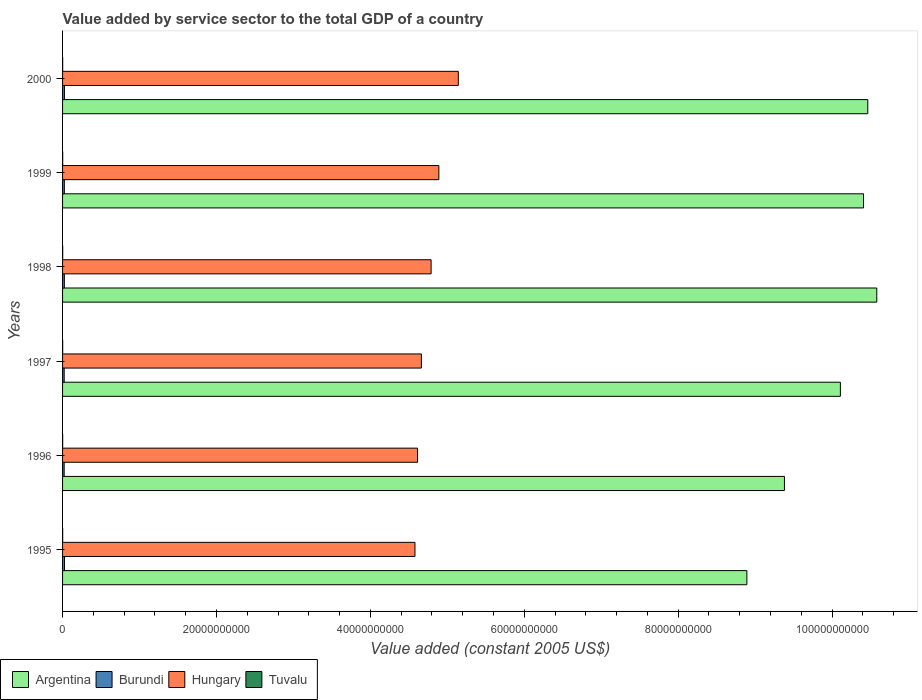Are the number of bars per tick equal to the number of legend labels?
Ensure brevity in your answer.  Yes. How many bars are there on the 1st tick from the bottom?
Make the answer very short. 4. What is the label of the 3rd group of bars from the top?
Make the answer very short. 1998. In how many cases, is the number of bars for a given year not equal to the number of legend labels?
Ensure brevity in your answer.  0. What is the value added by service sector in Burundi in 1998?
Ensure brevity in your answer.  2.31e+08. Across all years, what is the maximum value added by service sector in Argentina?
Your answer should be compact. 1.06e+11. Across all years, what is the minimum value added by service sector in Tuvalu?
Offer a very short reply. 1.20e+07. In which year was the value added by service sector in Hungary minimum?
Keep it short and to the point. 1995. What is the total value added by service sector in Hungary in the graph?
Ensure brevity in your answer.  2.87e+11. What is the difference between the value added by service sector in Burundi in 1996 and that in 1997?
Offer a terse response. -3.13e+06. What is the difference between the value added by service sector in Argentina in 1996 and the value added by service sector in Hungary in 1999?
Your answer should be very brief. 4.49e+1. What is the average value added by service sector in Hungary per year?
Ensure brevity in your answer.  4.78e+1. In the year 1999, what is the difference between the value added by service sector in Tuvalu and value added by service sector in Burundi?
Provide a short and direct response. -2.15e+08. What is the ratio of the value added by service sector in Hungary in 1995 to that in 1999?
Offer a terse response. 0.94. What is the difference between the highest and the second highest value added by service sector in Tuvalu?
Provide a short and direct response. 3.08e+05. What is the difference between the highest and the lowest value added by service sector in Tuvalu?
Your response must be concise. 4.40e+06. In how many years, is the value added by service sector in Hungary greater than the average value added by service sector in Hungary taken over all years?
Offer a very short reply. 3. Is the sum of the value added by service sector in Hungary in 1995 and 2000 greater than the maximum value added by service sector in Argentina across all years?
Make the answer very short. No. Is it the case that in every year, the sum of the value added by service sector in Hungary and value added by service sector in Burundi is greater than the sum of value added by service sector in Argentina and value added by service sector in Tuvalu?
Ensure brevity in your answer.  Yes. What does the 1st bar from the top in 1995 represents?
Ensure brevity in your answer.  Tuvalu. What does the 3rd bar from the bottom in 1995 represents?
Make the answer very short. Hungary. How many bars are there?
Provide a succinct answer. 24. Are all the bars in the graph horizontal?
Your answer should be very brief. Yes. How many years are there in the graph?
Provide a succinct answer. 6. How many legend labels are there?
Ensure brevity in your answer.  4. What is the title of the graph?
Give a very brief answer. Value added by service sector to the total GDP of a country. What is the label or title of the X-axis?
Your answer should be very brief. Value added (constant 2005 US$). What is the Value added (constant 2005 US$) in Argentina in 1995?
Keep it short and to the point. 8.89e+1. What is the Value added (constant 2005 US$) in Burundi in 1995?
Make the answer very short. 2.49e+08. What is the Value added (constant 2005 US$) in Hungary in 1995?
Make the answer very short. 4.58e+1. What is the Value added (constant 2005 US$) in Tuvalu in 1995?
Make the answer very short. 1.32e+07. What is the Value added (constant 2005 US$) in Argentina in 1996?
Keep it short and to the point. 9.38e+1. What is the Value added (constant 2005 US$) in Burundi in 1996?
Your response must be concise. 2.07e+08. What is the Value added (constant 2005 US$) of Hungary in 1996?
Make the answer very short. 4.61e+1. What is the Value added (constant 2005 US$) in Tuvalu in 1996?
Your response must be concise. 1.20e+07. What is the Value added (constant 2005 US$) in Argentina in 1997?
Your response must be concise. 1.01e+11. What is the Value added (constant 2005 US$) of Burundi in 1997?
Keep it short and to the point. 2.10e+08. What is the Value added (constant 2005 US$) of Hungary in 1997?
Offer a terse response. 4.66e+1. What is the Value added (constant 2005 US$) in Tuvalu in 1997?
Ensure brevity in your answer.  1.35e+07. What is the Value added (constant 2005 US$) in Argentina in 1998?
Provide a succinct answer. 1.06e+11. What is the Value added (constant 2005 US$) of Burundi in 1998?
Keep it short and to the point. 2.31e+08. What is the Value added (constant 2005 US$) of Hungary in 1998?
Your answer should be very brief. 4.79e+1. What is the Value added (constant 2005 US$) of Tuvalu in 1998?
Offer a very short reply. 1.64e+07. What is the Value added (constant 2005 US$) of Argentina in 1999?
Your answer should be compact. 1.04e+11. What is the Value added (constant 2005 US$) of Burundi in 1999?
Keep it short and to the point. 2.31e+08. What is the Value added (constant 2005 US$) of Hungary in 1999?
Your answer should be very brief. 4.89e+1. What is the Value added (constant 2005 US$) of Tuvalu in 1999?
Offer a very short reply. 1.61e+07. What is the Value added (constant 2005 US$) in Argentina in 2000?
Give a very brief answer. 1.05e+11. What is the Value added (constant 2005 US$) of Burundi in 2000?
Give a very brief answer. 2.44e+08. What is the Value added (constant 2005 US$) in Hungary in 2000?
Provide a short and direct response. 5.14e+1. What is the Value added (constant 2005 US$) of Tuvalu in 2000?
Give a very brief answer. 1.32e+07. Across all years, what is the maximum Value added (constant 2005 US$) of Argentina?
Your response must be concise. 1.06e+11. Across all years, what is the maximum Value added (constant 2005 US$) in Burundi?
Ensure brevity in your answer.  2.49e+08. Across all years, what is the maximum Value added (constant 2005 US$) of Hungary?
Offer a very short reply. 5.14e+1. Across all years, what is the maximum Value added (constant 2005 US$) in Tuvalu?
Ensure brevity in your answer.  1.64e+07. Across all years, what is the minimum Value added (constant 2005 US$) in Argentina?
Your response must be concise. 8.89e+1. Across all years, what is the minimum Value added (constant 2005 US$) of Burundi?
Provide a succinct answer. 2.07e+08. Across all years, what is the minimum Value added (constant 2005 US$) in Hungary?
Provide a succinct answer. 4.58e+1. Across all years, what is the minimum Value added (constant 2005 US$) in Tuvalu?
Keep it short and to the point. 1.20e+07. What is the total Value added (constant 2005 US$) of Argentina in the graph?
Your response must be concise. 5.98e+11. What is the total Value added (constant 2005 US$) in Burundi in the graph?
Your answer should be compact. 1.37e+09. What is the total Value added (constant 2005 US$) in Hungary in the graph?
Keep it short and to the point. 2.87e+11. What is the total Value added (constant 2005 US$) in Tuvalu in the graph?
Give a very brief answer. 8.42e+07. What is the difference between the Value added (constant 2005 US$) in Argentina in 1995 and that in 1996?
Offer a very short reply. -4.88e+09. What is the difference between the Value added (constant 2005 US$) of Burundi in 1995 and that in 1996?
Your response must be concise. 4.22e+07. What is the difference between the Value added (constant 2005 US$) of Hungary in 1995 and that in 1996?
Offer a very short reply. -3.36e+08. What is the difference between the Value added (constant 2005 US$) of Tuvalu in 1995 and that in 1996?
Your answer should be very brief. 1.20e+06. What is the difference between the Value added (constant 2005 US$) of Argentina in 1995 and that in 1997?
Your response must be concise. -1.21e+1. What is the difference between the Value added (constant 2005 US$) in Burundi in 1995 and that in 1997?
Offer a terse response. 3.91e+07. What is the difference between the Value added (constant 2005 US$) of Hungary in 1995 and that in 1997?
Ensure brevity in your answer.  -8.33e+08. What is the difference between the Value added (constant 2005 US$) of Tuvalu in 1995 and that in 1997?
Provide a succinct answer. -3.17e+05. What is the difference between the Value added (constant 2005 US$) of Argentina in 1995 and that in 1998?
Offer a terse response. -1.69e+1. What is the difference between the Value added (constant 2005 US$) of Burundi in 1995 and that in 1998?
Ensure brevity in your answer.  1.79e+07. What is the difference between the Value added (constant 2005 US$) of Hungary in 1995 and that in 1998?
Provide a short and direct response. -2.10e+09. What is the difference between the Value added (constant 2005 US$) in Tuvalu in 1995 and that in 1998?
Make the answer very short. -3.20e+06. What is the difference between the Value added (constant 2005 US$) in Argentina in 1995 and that in 1999?
Your response must be concise. -1.52e+1. What is the difference between the Value added (constant 2005 US$) in Burundi in 1995 and that in 1999?
Keep it short and to the point. 1.80e+07. What is the difference between the Value added (constant 2005 US$) in Hungary in 1995 and that in 1999?
Your answer should be very brief. -3.10e+09. What is the difference between the Value added (constant 2005 US$) in Tuvalu in 1995 and that in 1999?
Keep it short and to the point. -2.89e+06. What is the difference between the Value added (constant 2005 US$) of Argentina in 1995 and that in 2000?
Provide a succinct answer. -1.57e+1. What is the difference between the Value added (constant 2005 US$) in Burundi in 1995 and that in 2000?
Provide a short and direct response. 5.33e+06. What is the difference between the Value added (constant 2005 US$) of Hungary in 1995 and that in 2000?
Provide a short and direct response. -5.63e+09. What is the difference between the Value added (constant 2005 US$) in Tuvalu in 1995 and that in 2000?
Give a very brief answer. 6949.36. What is the difference between the Value added (constant 2005 US$) in Argentina in 1996 and that in 1997?
Keep it short and to the point. -7.27e+09. What is the difference between the Value added (constant 2005 US$) of Burundi in 1996 and that in 1997?
Provide a succinct answer. -3.13e+06. What is the difference between the Value added (constant 2005 US$) in Hungary in 1996 and that in 1997?
Provide a short and direct response. -4.97e+08. What is the difference between the Value added (constant 2005 US$) in Tuvalu in 1996 and that in 1997?
Provide a short and direct response. -1.52e+06. What is the difference between the Value added (constant 2005 US$) of Argentina in 1996 and that in 1998?
Keep it short and to the point. -1.20e+1. What is the difference between the Value added (constant 2005 US$) in Burundi in 1996 and that in 1998?
Ensure brevity in your answer.  -2.43e+07. What is the difference between the Value added (constant 2005 US$) of Hungary in 1996 and that in 1998?
Make the answer very short. -1.76e+09. What is the difference between the Value added (constant 2005 US$) of Tuvalu in 1996 and that in 1998?
Your response must be concise. -4.40e+06. What is the difference between the Value added (constant 2005 US$) of Argentina in 1996 and that in 1999?
Provide a short and direct response. -1.03e+1. What is the difference between the Value added (constant 2005 US$) in Burundi in 1996 and that in 1999?
Keep it short and to the point. -2.42e+07. What is the difference between the Value added (constant 2005 US$) of Hungary in 1996 and that in 1999?
Offer a very short reply. -2.77e+09. What is the difference between the Value added (constant 2005 US$) of Tuvalu in 1996 and that in 1999?
Make the answer very short. -4.09e+06. What is the difference between the Value added (constant 2005 US$) of Argentina in 1996 and that in 2000?
Offer a terse response. -1.08e+1. What is the difference between the Value added (constant 2005 US$) of Burundi in 1996 and that in 2000?
Your answer should be compact. -3.69e+07. What is the difference between the Value added (constant 2005 US$) of Hungary in 1996 and that in 2000?
Provide a succinct answer. -5.30e+09. What is the difference between the Value added (constant 2005 US$) of Tuvalu in 1996 and that in 2000?
Your answer should be compact. -1.19e+06. What is the difference between the Value added (constant 2005 US$) of Argentina in 1997 and that in 1998?
Offer a very short reply. -4.73e+09. What is the difference between the Value added (constant 2005 US$) in Burundi in 1997 and that in 1998?
Offer a terse response. -2.12e+07. What is the difference between the Value added (constant 2005 US$) of Hungary in 1997 and that in 1998?
Offer a terse response. -1.26e+09. What is the difference between the Value added (constant 2005 US$) in Tuvalu in 1997 and that in 1998?
Provide a succinct answer. -2.88e+06. What is the difference between the Value added (constant 2005 US$) in Argentina in 1997 and that in 1999?
Your response must be concise. -3.01e+09. What is the difference between the Value added (constant 2005 US$) of Burundi in 1997 and that in 1999?
Provide a succinct answer. -2.11e+07. What is the difference between the Value added (constant 2005 US$) of Hungary in 1997 and that in 1999?
Make the answer very short. -2.27e+09. What is the difference between the Value added (constant 2005 US$) in Tuvalu in 1997 and that in 1999?
Ensure brevity in your answer.  -2.58e+06. What is the difference between the Value added (constant 2005 US$) in Argentina in 1997 and that in 2000?
Your answer should be very brief. -3.56e+09. What is the difference between the Value added (constant 2005 US$) of Burundi in 1997 and that in 2000?
Offer a terse response. -3.38e+07. What is the difference between the Value added (constant 2005 US$) of Hungary in 1997 and that in 2000?
Ensure brevity in your answer.  -4.80e+09. What is the difference between the Value added (constant 2005 US$) of Tuvalu in 1997 and that in 2000?
Provide a succinct answer. 3.24e+05. What is the difference between the Value added (constant 2005 US$) in Argentina in 1998 and that in 1999?
Keep it short and to the point. 1.72e+09. What is the difference between the Value added (constant 2005 US$) of Burundi in 1998 and that in 1999?
Provide a succinct answer. 7.54e+04. What is the difference between the Value added (constant 2005 US$) of Hungary in 1998 and that in 1999?
Ensure brevity in your answer.  -1.01e+09. What is the difference between the Value added (constant 2005 US$) in Tuvalu in 1998 and that in 1999?
Your answer should be compact. 3.08e+05. What is the difference between the Value added (constant 2005 US$) in Argentina in 1998 and that in 2000?
Keep it short and to the point. 1.17e+09. What is the difference between the Value added (constant 2005 US$) of Burundi in 1998 and that in 2000?
Make the answer very short. -1.26e+07. What is the difference between the Value added (constant 2005 US$) of Hungary in 1998 and that in 2000?
Offer a terse response. -3.54e+09. What is the difference between the Value added (constant 2005 US$) of Tuvalu in 1998 and that in 2000?
Provide a succinct answer. 3.21e+06. What is the difference between the Value added (constant 2005 US$) of Argentina in 1999 and that in 2000?
Offer a very short reply. -5.52e+08. What is the difference between the Value added (constant 2005 US$) of Burundi in 1999 and that in 2000?
Your response must be concise. -1.27e+07. What is the difference between the Value added (constant 2005 US$) in Hungary in 1999 and that in 2000?
Offer a very short reply. -2.53e+09. What is the difference between the Value added (constant 2005 US$) in Tuvalu in 1999 and that in 2000?
Your answer should be very brief. 2.90e+06. What is the difference between the Value added (constant 2005 US$) in Argentina in 1995 and the Value added (constant 2005 US$) in Burundi in 1996?
Offer a terse response. 8.87e+1. What is the difference between the Value added (constant 2005 US$) of Argentina in 1995 and the Value added (constant 2005 US$) of Hungary in 1996?
Your response must be concise. 4.28e+1. What is the difference between the Value added (constant 2005 US$) of Argentina in 1995 and the Value added (constant 2005 US$) of Tuvalu in 1996?
Keep it short and to the point. 8.89e+1. What is the difference between the Value added (constant 2005 US$) in Burundi in 1995 and the Value added (constant 2005 US$) in Hungary in 1996?
Your answer should be very brief. -4.59e+1. What is the difference between the Value added (constant 2005 US$) in Burundi in 1995 and the Value added (constant 2005 US$) in Tuvalu in 1996?
Give a very brief answer. 2.37e+08. What is the difference between the Value added (constant 2005 US$) of Hungary in 1995 and the Value added (constant 2005 US$) of Tuvalu in 1996?
Offer a very short reply. 4.58e+1. What is the difference between the Value added (constant 2005 US$) in Argentina in 1995 and the Value added (constant 2005 US$) in Burundi in 1997?
Your answer should be compact. 8.87e+1. What is the difference between the Value added (constant 2005 US$) of Argentina in 1995 and the Value added (constant 2005 US$) of Hungary in 1997?
Offer a very short reply. 4.23e+1. What is the difference between the Value added (constant 2005 US$) in Argentina in 1995 and the Value added (constant 2005 US$) in Tuvalu in 1997?
Keep it short and to the point. 8.89e+1. What is the difference between the Value added (constant 2005 US$) in Burundi in 1995 and the Value added (constant 2005 US$) in Hungary in 1997?
Your answer should be compact. -4.64e+1. What is the difference between the Value added (constant 2005 US$) in Burundi in 1995 and the Value added (constant 2005 US$) in Tuvalu in 1997?
Keep it short and to the point. 2.36e+08. What is the difference between the Value added (constant 2005 US$) of Hungary in 1995 and the Value added (constant 2005 US$) of Tuvalu in 1997?
Provide a succinct answer. 4.58e+1. What is the difference between the Value added (constant 2005 US$) of Argentina in 1995 and the Value added (constant 2005 US$) of Burundi in 1998?
Offer a terse response. 8.87e+1. What is the difference between the Value added (constant 2005 US$) in Argentina in 1995 and the Value added (constant 2005 US$) in Hungary in 1998?
Your response must be concise. 4.10e+1. What is the difference between the Value added (constant 2005 US$) in Argentina in 1995 and the Value added (constant 2005 US$) in Tuvalu in 1998?
Your answer should be very brief. 8.89e+1. What is the difference between the Value added (constant 2005 US$) in Burundi in 1995 and the Value added (constant 2005 US$) in Hungary in 1998?
Provide a succinct answer. -4.76e+1. What is the difference between the Value added (constant 2005 US$) in Burundi in 1995 and the Value added (constant 2005 US$) in Tuvalu in 1998?
Ensure brevity in your answer.  2.33e+08. What is the difference between the Value added (constant 2005 US$) in Hungary in 1995 and the Value added (constant 2005 US$) in Tuvalu in 1998?
Your response must be concise. 4.58e+1. What is the difference between the Value added (constant 2005 US$) of Argentina in 1995 and the Value added (constant 2005 US$) of Burundi in 1999?
Ensure brevity in your answer.  8.87e+1. What is the difference between the Value added (constant 2005 US$) in Argentina in 1995 and the Value added (constant 2005 US$) in Hungary in 1999?
Your answer should be compact. 4.00e+1. What is the difference between the Value added (constant 2005 US$) of Argentina in 1995 and the Value added (constant 2005 US$) of Tuvalu in 1999?
Keep it short and to the point. 8.89e+1. What is the difference between the Value added (constant 2005 US$) of Burundi in 1995 and the Value added (constant 2005 US$) of Hungary in 1999?
Offer a very short reply. -4.86e+1. What is the difference between the Value added (constant 2005 US$) in Burundi in 1995 and the Value added (constant 2005 US$) in Tuvalu in 1999?
Your response must be concise. 2.33e+08. What is the difference between the Value added (constant 2005 US$) in Hungary in 1995 and the Value added (constant 2005 US$) in Tuvalu in 1999?
Offer a terse response. 4.58e+1. What is the difference between the Value added (constant 2005 US$) in Argentina in 1995 and the Value added (constant 2005 US$) in Burundi in 2000?
Make the answer very short. 8.87e+1. What is the difference between the Value added (constant 2005 US$) of Argentina in 1995 and the Value added (constant 2005 US$) of Hungary in 2000?
Your answer should be compact. 3.75e+1. What is the difference between the Value added (constant 2005 US$) of Argentina in 1995 and the Value added (constant 2005 US$) of Tuvalu in 2000?
Give a very brief answer. 8.89e+1. What is the difference between the Value added (constant 2005 US$) of Burundi in 1995 and the Value added (constant 2005 US$) of Hungary in 2000?
Ensure brevity in your answer.  -5.12e+1. What is the difference between the Value added (constant 2005 US$) of Burundi in 1995 and the Value added (constant 2005 US$) of Tuvalu in 2000?
Provide a succinct answer. 2.36e+08. What is the difference between the Value added (constant 2005 US$) in Hungary in 1995 and the Value added (constant 2005 US$) in Tuvalu in 2000?
Offer a terse response. 4.58e+1. What is the difference between the Value added (constant 2005 US$) of Argentina in 1996 and the Value added (constant 2005 US$) of Burundi in 1997?
Offer a terse response. 9.36e+1. What is the difference between the Value added (constant 2005 US$) of Argentina in 1996 and the Value added (constant 2005 US$) of Hungary in 1997?
Ensure brevity in your answer.  4.72e+1. What is the difference between the Value added (constant 2005 US$) of Argentina in 1996 and the Value added (constant 2005 US$) of Tuvalu in 1997?
Ensure brevity in your answer.  9.38e+1. What is the difference between the Value added (constant 2005 US$) in Burundi in 1996 and the Value added (constant 2005 US$) in Hungary in 1997?
Provide a succinct answer. -4.64e+1. What is the difference between the Value added (constant 2005 US$) in Burundi in 1996 and the Value added (constant 2005 US$) in Tuvalu in 1997?
Keep it short and to the point. 1.94e+08. What is the difference between the Value added (constant 2005 US$) of Hungary in 1996 and the Value added (constant 2005 US$) of Tuvalu in 1997?
Provide a succinct answer. 4.61e+1. What is the difference between the Value added (constant 2005 US$) of Argentina in 1996 and the Value added (constant 2005 US$) of Burundi in 1998?
Provide a short and direct response. 9.36e+1. What is the difference between the Value added (constant 2005 US$) of Argentina in 1996 and the Value added (constant 2005 US$) of Hungary in 1998?
Ensure brevity in your answer.  4.59e+1. What is the difference between the Value added (constant 2005 US$) of Argentina in 1996 and the Value added (constant 2005 US$) of Tuvalu in 1998?
Ensure brevity in your answer.  9.38e+1. What is the difference between the Value added (constant 2005 US$) in Burundi in 1996 and the Value added (constant 2005 US$) in Hungary in 1998?
Your answer should be compact. -4.77e+1. What is the difference between the Value added (constant 2005 US$) in Burundi in 1996 and the Value added (constant 2005 US$) in Tuvalu in 1998?
Ensure brevity in your answer.  1.91e+08. What is the difference between the Value added (constant 2005 US$) in Hungary in 1996 and the Value added (constant 2005 US$) in Tuvalu in 1998?
Provide a short and direct response. 4.61e+1. What is the difference between the Value added (constant 2005 US$) of Argentina in 1996 and the Value added (constant 2005 US$) of Burundi in 1999?
Make the answer very short. 9.36e+1. What is the difference between the Value added (constant 2005 US$) of Argentina in 1996 and the Value added (constant 2005 US$) of Hungary in 1999?
Give a very brief answer. 4.49e+1. What is the difference between the Value added (constant 2005 US$) of Argentina in 1996 and the Value added (constant 2005 US$) of Tuvalu in 1999?
Make the answer very short. 9.38e+1. What is the difference between the Value added (constant 2005 US$) in Burundi in 1996 and the Value added (constant 2005 US$) in Hungary in 1999?
Provide a short and direct response. -4.87e+1. What is the difference between the Value added (constant 2005 US$) in Burundi in 1996 and the Value added (constant 2005 US$) in Tuvalu in 1999?
Offer a very short reply. 1.91e+08. What is the difference between the Value added (constant 2005 US$) of Hungary in 1996 and the Value added (constant 2005 US$) of Tuvalu in 1999?
Your response must be concise. 4.61e+1. What is the difference between the Value added (constant 2005 US$) of Argentina in 1996 and the Value added (constant 2005 US$) of Burundi in 2000?
Your answer should be compact. 9.36e+1. What is the difference between the Value added (constant 2005 US$) of Argentina in 1996 and the Value added (constant 2005 US$) of Hungary in 2000?
Give a very brief answer. 4.24e+1. What is the difference between the Value added (constant 2005 US$) in Argentina in 1996 and the Value added (constant 2005 US$) in Tuvalu in 2000?
Provide a succinct answer. 9.38e+1. What is the difference between the Value added (constant 2005 US$) in Burundi in 1996 and the Value added (constant 2005 US$) in Hungary in 2000?
Make the answer very short. -5.12e+1. What is the difference between the Value added (constant 2005 US$) of Burundi in 1996 and the Value added (constant 2005 US$) of Tuvalu in 2000?
Your response must be concise. 1.94e+08. What is the difference between the Value added (constant 2005 US$) in Hungary in 1996 and the Value added (constant 2005 US$) in Tuvalu in 2000?
Ensure brevity in your answer.  4.61e+1. What is the difference between the Value added (constant 2005 US$) of Argentina in 1997 and the Value added (constant 2005 US$) of Burundi in 1998?
Your answer should be very brief. 1.01e+11. What is the difference between the Value added (constant 2005 US$) in Argentina in 1997 and the Value added (constant 2005 US$) in Hungary in 1998?
Your answer should be compact. 5.32e+1. What is the difference between the Value added (constant 2005 US$) of Argentina in 1997 and the Value added (constant 2005 US$) of Tuvalu in 1998?
Provide a succinct answer. 1.01e+11. What is the difference between the Value added (constant 2005 US$) in Burundi in 1997 and the Value added (constant 2005 US$) in Hungary in 1998?
Your response must be concise. -4.77e+1. What is the difference between the Value added (constant 2005 US$) of Burundi in 1997 and the Value added (constant 2005 US$) of Tuvalu in 1998?
Keep it short and to the point. 1.94e+08. What is the difference between the Value added (constant 2005 US$) in Hungary in 1997 and the Value added (constant 2005 US$) in Tuvalu in 1998?
Give a very brief answer. 4.66e+1. What is the difference between the Value added (constant 2005 US$) of Argentina in 1997 and the Value added (constant 2005 US$) of Burundi in 1999?
Make the answer very short. 1.01e+11. What is the difference between the Value added (constant 2005 US$) of Argentina in 1997 and the Value added (constant 2005 US$) of Hungary in 1999?
Your response must be concise. 5.22e+1. What is the difference between the Value added (constant 2005 US$) of Argentina in 1997 and the Value added (constant 2005 US$) of Tuvalu in 1999?
Give a very brief answer. 1.01e+11. What is the difference between the Value added (constant 2005 US$) of Burundi in 1997 and the Value added (constant 2005 US$) of Hungary in 1999?
Your answer should be compact. -4.87e+1. What is the difference between the Value added (constant 2005 US$) of Burundi in 1997 and the Value added (constant 2005 US$) of Tuvalu in 1999?
Your answer should be compact. 1.94e+08. What is the difference between the Value added (constant 2005 US$) of Hungary in 1997 and the Value added (constant 2005 US$) of Tuvalu in 1999?
Your answer should be compact. 4.66e+1. What is the difference between the Value added (constant 2005 US$) in Argentina in 1997 and the Value added (constant 2005 US$) in Burundi in 2000?
Make the answer very short. 1.01e+11. What is the difference between the Value added (constant 2005 US$) in Argentina in 1997 and the Value added (constant 2005 US$) in Hungary in 2000?
Give a very brief answer. 4.96e+1. What is the difference between the Value added (constant 2005 US$) of Argentina in 1997 and the Value added (constant 2005 US$) of Tuvalu in 2000?
Make the answer very short. 1.01e+11. What is the difference between the Value added (constant 2005 US$) of Burundi in 1997 and the Value added (constant 2005 US$) of Hungary in 2000?
Provide a short and direct response. -5.12e+1. What is the difference between the Value added (constant 2005 US$) in Burundi in 1997 and the Value added (constant 2005 US$) in Tuvalu in 2000?
Your response must be concise. 1.97e+08. What is the difference between the Value added (constant 2005 US$) of Hungary in 1997 and the Value added (constant 2005 US$) of Tuvalu in 2000?
Provide a short and direct response. 4.66e+1. What is the difference between the Value added (constant 2005 US$) of Argentina in 1998 and the Value added (constant 2005 US$) of Burundi in 1999?
Make the answer very short. 1.06e+11. What is the difference between the Value added (constant 2005 US$) of Argentina in 1998 and the Value added (constant 2005 US$) of Hungary in 1999?
Provide a short and direct response. 5.69e+1. What is the difference between the Value added (constant 2005 US$) of Argentina in 1998 and the Value added (constant 2005 US$) of Tuvalu in 1999?
Offer a terse response. 1.06e+11. What is the difference between the Value added (constant 2005 US$) in Burundi in 1998 and the Value added (constant 2005 US$) in Hungary in 1999?
Provide a short and direct response. -4.87e+1. What is the difference between the Value added (constant 2005 US$) in Burundi in 1998 and the Value added (constant 2005 US$) in Tuvalu in 1999?
Offer a terse response. 2.15e+08. What is the difference between the Value added (constant 2005 US$) of Hungary in 1998 and the Value added (constant 2005 US$) of Tuvalu in 1999?
Make the answer very short. 4.79e+1. What is the difference between the Value added (constant 2005 US$) in Argentina in 1998 and the Value added (constant 2005 US$) in Burundi in 2000?
Ensure brevity in your answer.  1.06e+11. What is the difference between the Value added (constant 2005 US$) in Argentina in 1998 and the Value added (constant 2005 US$) in Hungary in 2000?
Give a very brief answer. 5.44e+1. What is the difference between the Value added (constant 2005 US$) in Argentina in 1998 and the Value added (constant 2005 US$) in Tuvalu in 2000?
Offer a terse response. 1.06e+11. What is the difference between the Value added (constant 2005 US$) of Burundi in 1998 and the Value added (constant 2005 US$) of Hungary in 2000?
Keep it short and to the point. -5.12e+1. What is the difference between the Value added (constant 2005 US$) in Burundi in 1998 and the Value added (constant 2005 US$) in Tuvalu in 2000?
Make the answer very short. 2.18e+08. What is the difference between the Value added (constant 2005 US$) in Hungary in 1998 and the Value added (constant 2005 US$) in Tuvalu in 2000?
Keep it short and to the point. 4.79e+1. What is the difference between the Value added (constant 2005 US$) in Argentina in 1999 and the Value added (constant 2005 US$) in Burundi in 2000?
Provide a short and direct response. 1.04e+11. What is the difference between the Value added (constant 2005 US$) in Argentina in 1999 and the Value added (constant 2005 US$) in Hungary in 2000?
Ensure brevity in your answer.  5.27e+1. What is the difference between the Value added (constant 2005 US$) of Argentina in 1999 and the Value added (constant 2005 US$) of Tuvalu in 2000?
Keep it short and to the point. 1.04e+11. What is the difference between the Value added (constant 2005 US$) of Burundi in 1999 and the Value added (constant 2005 US$) of Hungary in 2000?
Your answer should be very brief. -5.12e+1. What is the difference between the Value added (constant 2005 US$) in Burundi in 1999 and the Value added (constant 2005 US$) in Tuvalu in 2000?
Make the answer very short. 2.18e+08. What is the difference between the Value added (constant 2005 US$) of Hungary in 1999 and the Value added (constant 2005 US$) of Tuvalu in 2000?
Offer a terse response. 4.89e+1. What is the average Value added (constant 2005 US$) of Argentina per year?
Provide a succinct answer. 9.97e+1. What is the average Value added (constant 2005 US$) in Burundi per year?
Provide a succinct answer. 2.29e+08. What is the average Value added (constant 2005 US$) of Hungary per year?
Provide a succinct answer. 4.78e+1. What is the average Value added (constant 2005 US$) of Tuvalu per year?
Provide a short and direct response. 1.40e+07. In the year 1995, what is the difference between the Value added (constant 2005 US$) in Argentina and Value added (constant 2005 US$) in Burundi?
Your response must be concise. 8.87e+1. In the year 1995, what is the difference between the Value added (constant 2005 US$) of Argentina and Value added (constant 2005 US$) of Hungary?
Offer a very short reply. 4.31e+1. In the year 1995, what is the difference between the Value added (constant 2005 US$) of Argentina and Value added (constant 2005 US$) of Tuvalu?
Your answer should be compact. 8.89e+1. In the year 1995, what is the difference between the Value added (constant 2005 US$) in Burundi and Value added (constant 2005 US$) in Hungary?
Provide a succinct answer. -4.55e+1. In the year 1995, what is the difference between the Value added (constant 2005 US$) of Burundi and Value added (constant 2005 US$) of Tuvalu?
Provide a short and direct response. 2.36e+08. In the year 1995, what is the difference between the Value added (constant 2005 US$) in Hungary and Value added (constant 2005 US$) in Tuvalu?
Make the answer very short. 4.58e+1. In the year 1996, what is the difference between the Value added (constant 2005 US$) of Argentina and Value added (constant 2005 US$) of Burundi?
Offer a very short reply. 9.36e+1. In the year 1996, what is the difference between the Value added (constant 2005 US$) in Argentina and Value added (constant 2005 US$) in Hungary?
Offer a very short reply. 4.77e+1. In the year 1996, what is the difference between the Value added (constant 2005 US$) in Argentina and Value added (constant 2005 US$) in Tuvalu?
Offer a terse response. 9.38e+1. In the year 1996, what is the difference between the Value added (constant 2005 US$) of Burundi and Value added (constant 2005 US$) of Hungary?
Ensure brevity in your answer.  -4.59e+1. In the year 1996, what is the difference between the Value added (constant 2005 US$) in Burundi and Value added (constant 2005 US$) in Tuvalu?
Keep it short and to the point. 1.95e+08. In the year 1996, what is the difference between the Value added (constant 2005 US$) of Hungary and Value added (constant 2005 US$) of Tuvalu?
Your answer should be compact. 4.61e+1. In the year 1997, what is the difference between the Value added (constant 2005 US$) in Argentina and Value added (constant 2005 US$) in Burundi?
Give a very brief answer. 1.01e+11. In the year 1997, what is the difference between the Value added (constant 2005 US$) in Argentina and Value added (constant 2005 US$) in Hungary?
Make the answer very short. 5.44e+1. In the year 1997, what is the difference between the Value added (constant 2005 US$) in Argentina and Value added (constant 2005 US$) in Tuvalu?
Provide a short and direct response. 1.01e+11. In the year 1997, what is the difference between the Value added (constant 2005 US$) in Burundi and Value added (constant 2005 US$) in Hungary?
Give a very brief answer. -4.64e+1. In the year 1997, what is the difference between the Value added (constant 2005 US$) in Burundi and Value added (constant 2005 US$) in Tuvalu?
Your answer should be compact. 1.97e+08. In the year 1997, what is the difference between the Value added (constant 2005 US$) of Hungary and Value added (constant 2005 US$) of Tuvalu?
Ensure brevity in your answer.  4.66e+1. In the year 1998, what is the difference between the Value added (constant 2005 US$) in Argentina and Value added (constant 2005 US$) in Burundi?
Provide a short and direct response. 1.06e+11. In the year 1998, what is the difference between the Value added (constant 2005 US$) in Argentina and Value added (constant 2005 US$) in Hungary?
Your answer should be compact. 5.79e+1. In the year 1998, what is the difference between the Value added (constant 2005 US$) of Argentina and Value added (constant 2005 US$) of Tuvalu?
Your response must be concise. 1.06e+11. In the year 1998, what is the difference between the Value added (constant 2005 US$) in Burundi and Value added (constant 2005 US$) in Hungary?
Your answer should be very brief. -4.77e+1. In the year 1998, what is the difference between the Value added (constant 2005 US$) of Burundi and Value added (constant 2005 US$) of Tuvalu?
Give a very brief answer. 2.15e+08. In the year 1998, what is the difference between the Value added (constant 2005 US$) of Hungary and Value added (constant 2005 US$) of Tuvalu?
Your answer should be compact. 4.79e+1. In the year 1999, what is the difference between the Value added (constant 2005 US$) in Argentina and Value added (constant 2005 US$) in Burundi?
Your response must be concise. 1.04e+11. In the year 1999, what is the difference between the Value added (constant 2005 US$) in Argentina and Value added (constant 2005 US$) in Hungary?
Provide a succinct answer. 5.52e+1. In the year 1999, what is the difference between the Value added (constant 2005 US$) in Argentina and Value added (constant 2005 US$) in Tuvalu?
Your answer should be compact. 1.04e+11. In the year 1999, what is the difference between the Value added (constant 2005 US$) in Burundi and Value added (constant 2005 US$) in Hungary?
Your answer should be compact. -4.87e+1. In the year 1999, what is the difference between the Value added (constant 2005 US$) in Burundi and Value added (constant 2005 US$) in Tuvalu?
Your answer should be very brief. 2.15e+08. In the year 1999, what is the difference between the Value added (constant 2005 US$) of Hungary and Value added (constant 2005 US$) of Tuvalu?
Offer a very short reply. 4.89e+1. In the year 2000, what is the difference between the Value added (constant 2005 US$) of Argentina and Value added (constant 2005 US$) of Burundi?
Offer a very short reply. 1.04e+11. In the year 2000, what is the difference between the Value added (constant 2005 US$) of Argentina and Value added (constant 2005 US$) of Hungary?
Make the answer very short. 5.32e+1. In the year 2000, what is the difference between the Value added (constant 2005 US$) of Argentina and Value added (constant 2005 US$) of Tuvalu?
Your response must be concise. 1.05e+11. In the year 2000, what is the difference between the Value added (constant 2005 US$) in Burundi and Value added (constant 2005 US$) in Hungary?
Make the answer very short. -5.12e+1. In the year 2000, what is the difference between the Value added (constant 2005 US$) in Burundi and Value added (constant 2005 US$) in Tuvalu?
Offer a terse response. 2.31e+08. In the year 2000, what is the difference between the Value added (constant 2005 US$) of Hungary and Value added (constant 2005 US$) of Tuvalu?
Keep it short and to the point. 5.14e+1. What is the ratio of the Value added (constant 2005 US$) in Argentina in 1995 to that in 1996?
Your answer should be very brief. 0.95. What is the ratio of the Value added (constant 2005 US$) of Burundi in 1995 to that in 1996?
Keep it short and to the point. 1.2. What is the ratio of the Value added (constant 2005 US$) in Tuvalu in 1995 to that in 1996?
Your response must be concise. 1.1. What is the ratio of the Value added (constant 2005 US$) in Argentina in 1995 to that in 1997?
Provide a succinct answer. 0.88. What is the ratio of the Value added (constant 2005 US$) in Burundi in 1995 to that in 1997?
Make the answer very short. 1.19. What is the ratio of the Value added (constant 2005 US$) of Hungary in 1995 to that in 1997?
Offer a very short reply. 0.98. What is the ratio of the Value added (constant 2005 US$) in Tuvalu in 1995 to that in 1997?
Your answer should be compact. 0.98. What is the ratio of the Value added (constant 2005 US$) of Argentina in 1995 to that in 1998?
Offer a very short reply. 0.84. What is the ratio of the Value added (constant 2005 US$) in Burundi in 1995 to that in 1998?
Offer a very short reply. 1.08. What is the ratio of the Value added (constant 2005 US$) in Hungary in 1995 to that in 1998?
Keep it short and to the point. 0.96. What is the ratio of the Value added (constant 2005 US$) of Tuvalu in 1995 to that in 1998?
Keep it short and to the point. 0.8. What is the ratio of the Value added (constant 2005 US$) of Argentina in 1995 to that in 1999?
Make the answer very short. 0.85. What is the ratio of the Value added (constant 2005 US$) of Burundi in 1995 to that in 1999?
Offer a terse response. 1.08. What is the ratio of the Value added (constant 2005 US$) in Hungary in 1995 to that in 1999?
Offer a terse response. 0.94. What is the ratio of the Value added (constant 2005 US$) in Tuvalu in 1995 to that in 1999?
Offer a terse response. 0.82. What is the ratio of the Value added (constant 2005 US$) of Argentina in 1995 to that in 2000?
Make the answer very short. 0.85. What is the ratio of the Value added (constant 2005 US$) of Burundi in 1995 to that in 2000?
Keep it short and to the point. 1.02. What is the ratio of the Value added (constant 2005 US$) in Hungary in 1995 to that in 2000?
Ensure brevity in your answer.  0.89. What is the ratio of the Value added (constant 2005 US$) of Argentina in 1996 to that in 1997?
Offer a very short reply. 0.93. What is the ratio of the Value added (constant 2005 US$) in Burundi in 1996 to that in 1997?
Keep it short and to the point. 0.99. What is the ratio of the Value added (constant 2005 US$) of Hungary in 1996 to that in 1997?
Provide a succinct answer. 0.99. What is the ratio of the Value added (constant 2005 US$) of Tuvalu in 1996 to that in 1997?
Your answer should be very brief. 0.89. What is the ratio of the Value added (constant 2005 US$) in Argentina in 1996 to that in 1998?
Provide a succinct answer. 0.89. What is the ratio of the Value added (constant 2005 US$) of Burundi in 1996 to that in 1998?
Offer a very short reply. 0.89. What is the ratio of the Value added (constant 2005 US$) of Hungary in 1996 to that in 1998?
Keep it short and to the point. 0.96. What is the ratio of the Value added (constant 2005 US$) of Tuvalu in 1996 to that in 1998?
Your response must be concise. 0.73. What is the ratio of the Value added (constant 2005 US$) of Argentina in 1996 to that in 1999?
Your answer should be very brief. 0.9. What is the ratio of the Value added (constant 2005 US$) in Burundi in 1996 to that in 1999?
Your response must be concise. 0.9. What is the ratio of the Value added (constant 2005 US$) of Hungary in 1996 to that in 1999?
Provide a succinct answer. 0.94. What is the ratio of the Value added (constant 2005 US$) in Tuvalu in 1996 to that in 1999?
Offer a very short reply. 0.75. What is the ratio of the Value added (constant 2005 US$) in Argentina in 1996 to that in 2000?
Your answer should be very brief. 0.9. What is the ratio of the Value added (constant 2005 US$) of Burundi in 1996 to that in 2000?
Give a very brief answer. 0.85. What is the ratio of the Value added (constant 2005 US$) in Hungary in 1996 to that in 2000?
Your answer should be compact. 0.9. What is the ratio of the Value added (constant 2005 US$) in Tuvalu in 1996 to that in 2000?
Provide a succinct answer. 0.91. What is the ratio of the Value added (constant 2005 US$) of Argentina in 1997 to that in 1998?
Make the answer very short. 0.96. What is the ratio of the Value added (constant 2005 US$) in Burundi in 1997 to that in 1998?
Ensure brevity in your answer.  0.91. What is the ratio of the Value added (constant 2005 US$) of Hungary in 1997 to that in 1998?
Your response must be concise. 0.97. What is the ratio of the Value added (constant 2005 US$) in Tuvalu in 1997 to that in 1998?
Provide a succinct answer. 0.82. What is the ratio of the Value added (constant 2005 US$) in Argentina in 1997 to that in 1999?
Your response must be concise. 0.97. What is the ratio of the Value added (constant 2005 US$) in Burundi in 1997 to that in 1999?
Your answer should be very brief. 0.91. What is the ratio of the Value added (constant 2005 US$) in Hungary in 1997 to that in 1999?
Your answer should be very brief. 0.95. What is the ratio of the Value added (constant 2005 US$) in Tuvalu in 1997 to that in 1999?
Your answer should be compact. 0.84. What is the ratio of the Value added (constant 2005 US$) in Argentina in 1997 to that in 2000?
Offer a very short reply. 0.97. What is the ratio of the Value added (constant 2005 US$) of Burundi in 1997 to that in 2000?
Your answer should be very brief. 0.86. What is the ratio of the Value added (constant 2005 US$) of Hungary in 1997 to that in 2000?
Provide a succinct answer. 0.91. What is the ratio of the Value added (constant 2005 US$) of Tuvalu in 1997 to that in 2000?
Provide a succinct answer. 1.02. What is the ratio of the Value added (constant 2005 US$) in Argentina in 1998 to that in 1999?
Give a very brief answer. 1.02. What is the ratio of the Value added (constant 2005 US$) of Hungary in 1998 to that in 1999?
Keep it short and to the point. 0.98. What is the ratio of the Value added (constant 2005 US$) in Tuvalu in 1998 to that in 1999?
Ensure brevity in your answer.  1.02. What is the ratio of the Value added (constant 2005 US$) of Argentina in 1998 to that in 2000?
Make the answer very short. 1.01. What is the ratio of the Value added (constant 2005 US$) of Burundi in 1998 to that in 2000?
Offer a very short reply. 0.95. What is the ratio of the Value added (constant 2005 US$) in Hungary in 1998 to that in 2000?
Provide a short and direct response. 0.93. What is the ratio of the Value added (constant 2005 US$) in Tuvalu in 1998 to that in 2000?
Give a very brief answer. 1.24. What is the ratio of the Value added (constant 2005 US$) of Argentina in 1999 to that in 2000?
Give a very brief answer. 0.99. What is the ratio of the Value added (constant 2005 US$) of Burundi in 1999 to that in 2000?
Give a very brief answer. 0.95. What is the ratio of the Value added (constant 2005 US$) of Hungary in 1999 to that in 2000?
Provide a short and direct response. 0.95. What is the ratio of the Value added (constant 2005 US$) in Tuvalu in 1999 to that in 2000?
Provide a short and direct response. 1.22. What is the difference between the highest and the second highest Value added (constant 2005 US$) in Argentina?
Your answer should be compact. 1.17e+09. What is the difference between the highest and the second highest Value added (constant 2005 US$) of Burundi?
Keep it short and to the point. 5.33e+06. What is the difference between the highest and the second highest Value added (constant 2005 US$) of Hungary?
Offer a very short reply. 2.53e+09. What is the difference between the highest and the second highest Value added (constant 2005 US$) in Tuvalu?
Provide a short and direct response. 3.08e+05. What is the difference between the highest and the lowest Value added (constant 2005 US$) in Argentina?
Provide a short and direct response. 1.69e+1. What is the difference between the highest and the lowest Value added (constant 2005 US$) in Burundi?
Offer a terse response. 4.22e+07. What is the difference between the highest and the lowest Value added (constant 2005 US$) of Hungary?
Your response must be concise. 5.63e+09. What is the difference between the highest and the lowest Value added (constant 2005 US$) in Tuvalu?
Provide a succinct answer. 4.40e+06. 